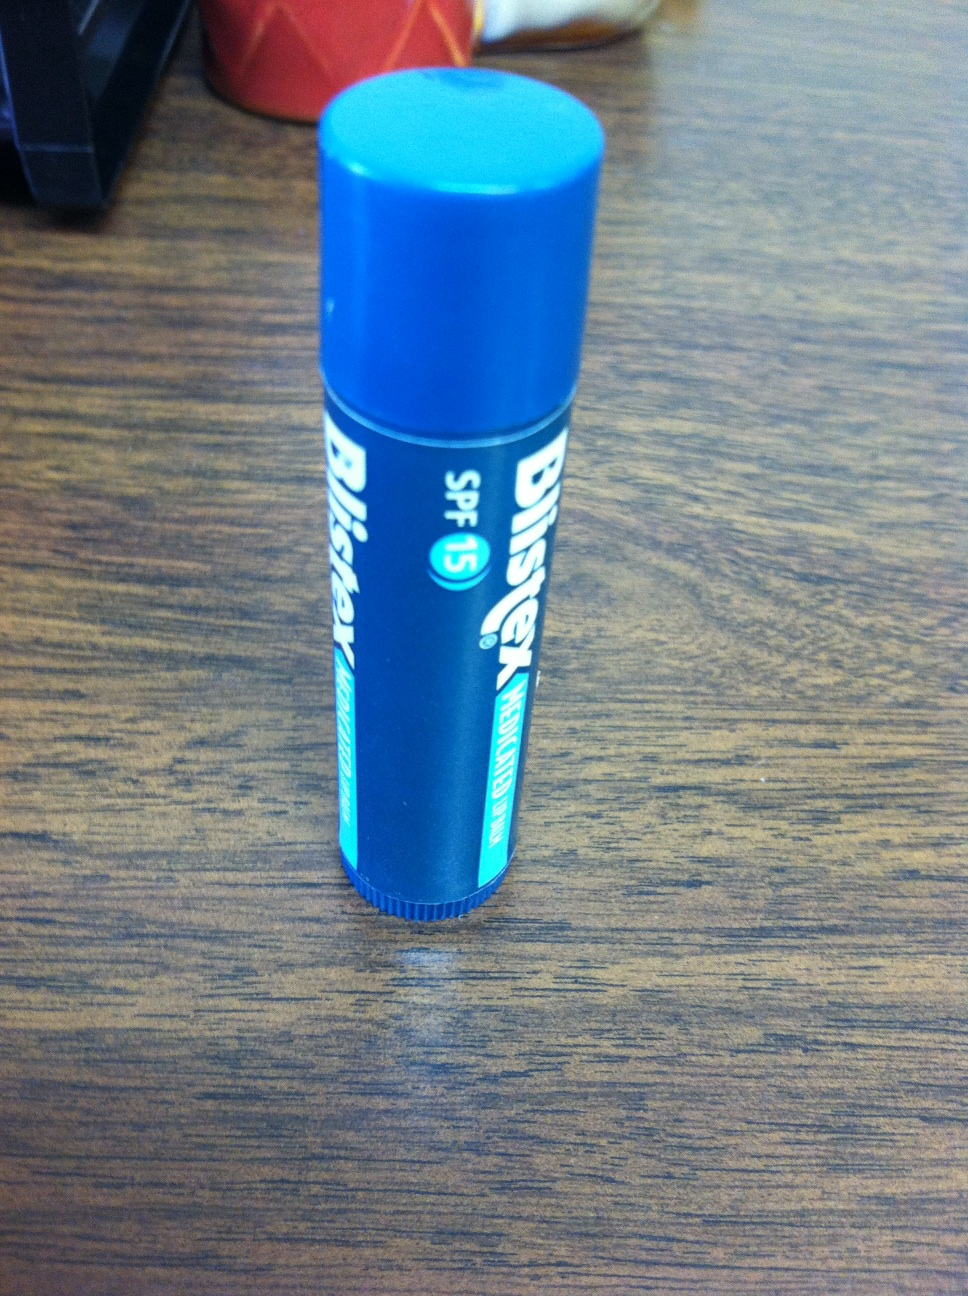Imagine this chapstick was discovered in an archaeological dig centuries into the future. What might people think it was used for? Centuries into the future, if archaeologists discovered this chapstick, they might theorize that it was a symbol of status or an artifact used in ancient beauty rituals. They could imagine that its soothing and protective properties were revered, and it possibly played a role in ceremonial preparations or daily grooming routines. Its 'SPF 15' label might intrigue them, leading to speculations on how ancient civilizations protected themselves from harsh climates and the importance of sun protection in their daily lives. The compact and durable design could also make them consider it was a highly valued personal item, passed down through generations as a treasured relic. Alternatively, they might think it was a small container for a miracle cure or a medicinal balm used to treat common ailments of the past. The multifunctional nature of the chapstick could lead to fascinating discussions on how people creatively used everyday items to enhance their quality of life, understanding ancient health and wellness practices. 